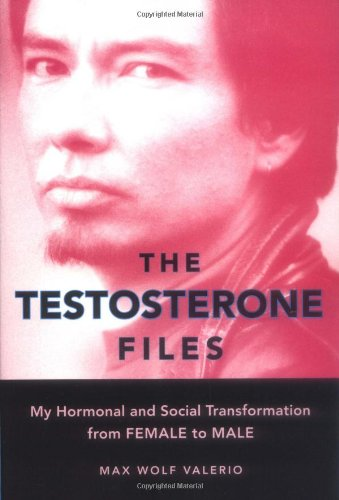Is this book related to Gay & Lesbian? Yes, it relates closely to LGBTQ+ themes, specifically focusing on transgender issues and personal growth within these communities. 